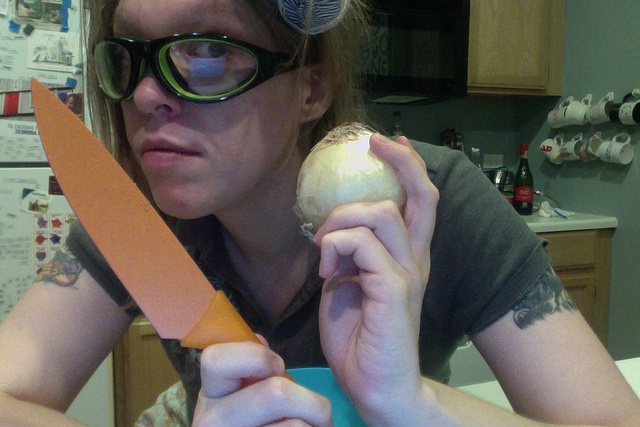Describe the objects in this image and their specific colors. I can see people in lightgray, black, darkgray, and gray tones, refrigerator in lightgray, darkgray, beige, gray, and darkgreen tones, knife in lightgray, salmon, and olive tones, bowl in lightgray and teal tones, and bottle in lightgray, black, maroon, gray, and darkgreen tones in this image. 